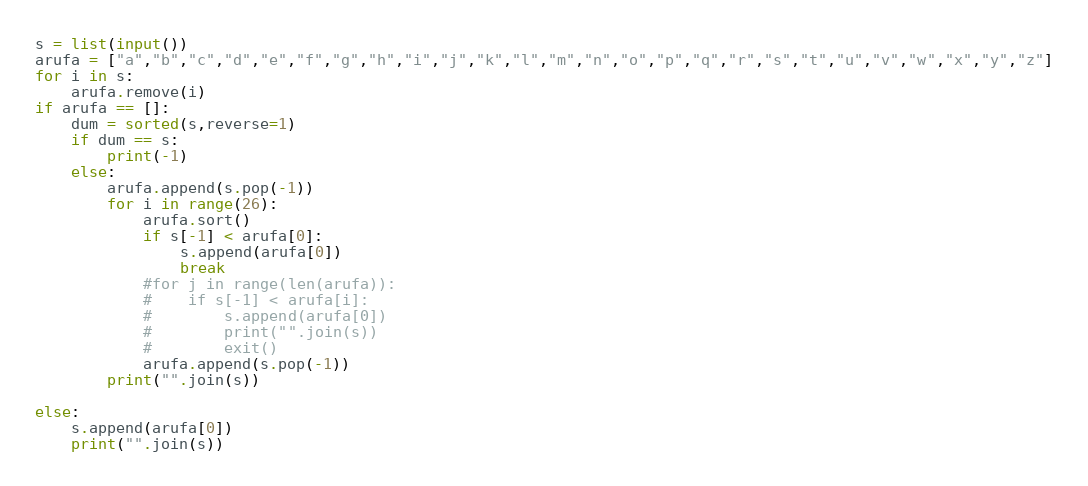Convert code to text. <code><loc_0><loc_0><loc_500><loc_500><_Python_>s = list(input())
arufa = ["a","b","c","d","e","f","g","h","i","j","k","l","m","n","o","p","q","r","s","t","u","v","w","x","y","z"]
for i in s:
    arufa.remove(i)
if arufa == []:
    dum = sorted(s,reverse=1)
    if dum == s:
        print(-1)
    else:
        arufa.append(s.pop(-1))
        for i in range(26):
            arufa.sort()
            if s[-1] < arufa[0]:
                s.append(arufa[0])
                break
            #for j in range(len(arufa)):
            #    if s[-1] < arufa[i]:
            #        s.append(arufa[0])
            #        print("".join(s))
            #        exit()
            arufa.append(s.pop(-1))
        print("".join(s))

else:
    s.append(arufa[0])
    print("".join(s))
</code> 